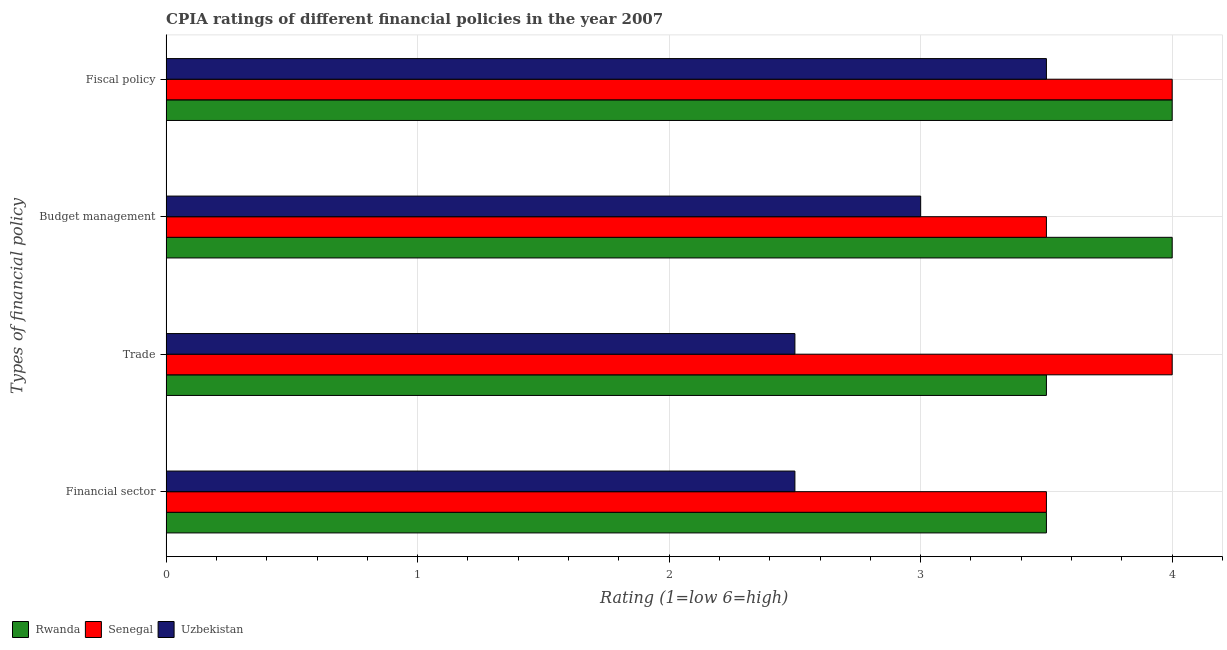How many groups of bars are there?
Keep it short and to the point. 4. Are the number of bars per tick equal to the number of legend labels?
Your response must be concise. Yes. Are the number of bars on each tick of the Y-axis equal?
Provide a short and direct response. Yes. How many bars are there on the 4th tick from the top?
Ensure brevity in your answer.  3. What is the label of the 3rd group of bars from the top?
Your answer should be very brief. Trade. Across all countries, what is the minimum cpia rating of financial sector?
Your answer should be compact. 2.5. In which country was the cpia rating of financial sector maximum?
Your answer should be compact. Rwanda. In which country was the cpia rating of trade minimum?
Provide a short and direct response. Uzbekistan. What is the total cpia rating of budget management in the graph?
Your response must be concise. 10.5. What is the difference between the cpia rating of trade in Rwanda and that in Senegal?
Your answer should be compact. -0.5. What is the difference between the cpia rating of financial sector and cpia rating of fiscal policy in Senegal?
Give a very brief answer. -0.5. What is the ratio of the cpia rating of trade in Senegal to that in Rwanda?
Give a very brief answer. 1.14. Is the cpia rating of trade in Senegal less than that in Rwanda?
Your answer should be very brief. No. In how many countries, is the cpia rating of financial sector greater than the average cpia rating of financial sector taken over all countries?
Your response must be concise. 2. Is it the case that in every country, the sum of the cpia rating of financial sector and cpia rating of fiscal policy is greater than the sum of cpia rating of trade and cpia rating of budget management?
Provide a short and direct response. No. What does the 3rd bar from the top in Fiscal policy represents?
Give a very brief answer. Rwanda. What does the 2nd bar from the bottom in Financial sector represents?
Offer a terse response. Senegal. Is it the case that in every country, the sum of the cpia rating of financial sector and cpia rating of trade is greater than the cpia rating of budget management?
Your answer should be very brief. Yes. How many countries are there in the graph?
Offer a terse response. 3. Are the values on the major ticks of X-axis written in scientific E-notation?
Make the answer very short. No. Does the graph contain any zero values?
Keep it short and to the point. No. Does the graph contain grids?
Your answer should be compact. Yes. Where does the legend appear in the graph?
Your answer should be very brief. Bottom left. What is the title of the graph?
Ensure brevity in your answer.  CPIA ratings of different financial policies in the year 2007. Does "Serbia" appear as one of the legend labels in the graph?
Offer a terse response. No. What is the label or title of the Y-axis?
Ensure brevity in your answer.  Types of financial policy. What is the Rating (1=low 6=high) of Rwanda in Financial sector?
Offer a very short reply. 3.5. What is the Rating (1=low 6=high) in Uzbekistan in Financial sector?
Provide a short and direct response. 2.5. What is the Rating (1=low 6=high) of Uzbekistan in Trade?
Make the answer very short. 2.5. What is the Rating (1=low 6=high) of Senegal in Budget management?
Give a very brief answer. 3.5. What is the Rating (1=low 6=high) of Rwanda in Fiscal policy?
Provide a short and direct response. 4. What is the Rating (1=low 6=high) in Uzbekistan in Fiscal policy?
Ensure brevity in your answer.  3.5. Across all Types of financial policy, what is the maximum Rating (1=low 6=high) of Senegal?
Your response must be concise. 4. Across all Types of financial policy, what is the maximum Rating (1=low 6=high) in Uzbekistan?
Make the answer very short. 3.5. Across all Types of financial policy, what is the minimum Rating (1=low 6=high) in Rwanda?
Provide a short and direct response. 3.5. What is the total Rating (1=low 6=high) of Rwanda in the graph?
Provide a short and direct response. 15. What is the total Rating (1=low 6=high) of Senegal in the graph?
Your response must be concise. 15. What is the difference between the Rating (1=low 6=high) in Senegal in Financial sector and that in Trade?
Your answer should be compact. -0.5. What is the difference between the Rating (1=low 6=high) in Rwanda in Financial sector and that in Budget management?
Keep it short and to the point. -0.5. What is the difference between the Rating (1=low 6=high) of Senegal in Financial sector and that in Budget management?
Offer a very short reply. 0. What is the difference between the Rating (1=low 6=high) in Senegal in Financial sector and that in Fiscal policy?
Offer a terse response. -0.5. What is the difference between the Rating (1=low 6=high) of Rwanda in Trade and that in Budget management?
Ensure brevity in your answer.  -0.5. What is the difference between the Rating (1=low 6=high) in Senegal in Trade and that in Fiscal policy?
Ensure brevity in your answer.  0. What is the difference between the Rating (1=low 6=high) of Senegal in Budget management and that in Fiscal policy?
Your response must be concise. -0.5. What is the difference between the Rating (1=low 6=high) in Rwanda in Financial sector and the Rating (1=low 6=high) in Senegal in Trade?
Offer a terse response. -0.5. What is the difference between the Rating (1=low 6=high) in Rwanda in Financial sector and the Rating (1=low 6=high) in Uzbekistan in Trade?
Your answer should be very brief. 1. What is the difference between the Rating (1=low 6=high) of Rwanda in Financial sector and the Rating (1=low 6=high) of Uzbekistan in Budget management?
Offer a very short reply. 0.5. What is the difference between the Rating (1=low 6=high) of Rwanda in Financial sector and the Rating (1=low 6=high) of Uzbekistan in Fiscal policy?
Provide a succinct answer. 0. What is the difference between the Rating (1=low 6=high) of Senegal in Trade and the Rating (1=low 6=high) of Uzbekistan in Budget management?
Your response must be concise. 1. What is the difference between the Rating (1=low 6=high) of Rwanda in Budget management and the Rating (1=low 6=high) of Uzbekistan in Fiscal policy?
Make the answer very short. 0.5. What is the average Rating (1=low 6=high) of Rwanda per Types of financial policy?
Give a very brief answer. 3.75. What is the average Rating (1=low 6=high) in Senegal per Types of financial policy?
Provide a succinct answer. 3.75. What is the average Rating (1=low 6=high) in Uzbekistan per Types of financial policy?
Offer a terse response. 2.88. What is the difference between the Rating (1=low 6=high) in Senegal and Rating (1=low 6=high) in Uzbekistan in Financial sector?
Ensure brevity in your answer.  1. What is the difference between the Rating (1=low 6=high) of Rwanda and Rating (1=low 6=high) of Senegal in Trade?
Provide a succinct answer. -0.5. What is the difference between the Rating (1=low 6=high) in Rwanda and Rating (1=low 6=high) in Uzbekistan in Trade?
Offer a terse response. 1. What is the difference between the Rating (1=low 6=high) in Rwanda and Rating (1=low 6=high) in Senegal in Budget management?
Give a very brief answer. 0.5. What is the difference between the Rating (1=low 6=high) in Rwanda and Rating (1=low 6=high) in Uzbekistan in Budget management?
Offer a terse response. 1. What is the difference between the Rating (1=low 6=high) in Senegal and Rating (1=low 6=high) in Uzbekistan in Budget management?
Offer a very short reply. 0.5. What is the difference between the Rating (1=low 6=high) of Rwanda and Rating (1=low 6=high) of Uzbekistan in Fiscal policy?
Offer a terse response. 0.5. What is the ratio of the Rating (1=low 6=high) in Rwanda in Financial sector to that in Trade?
Your response must be concise. 1. What is the ratio of the Rating (1=low 6=high) in Senegal in Financial sector to that in Trade?
Give a very brief answer. 0.88. What is the ratio of the Rating (1=low 6=high) of Uzbekistan in Financial sector to that in Trade?
Provide a succinct answer. 1. What is the ratio of the Rating (1=low 6=high) of Rwanda in Financial sector to that in Budget management?
Keep it short and to the point. 0.88. What is the ratio of the Rating (1=low 6=high) in Rwanda in Financial sector to that in Fiscal policy?
Keep it short and to the point. 0.88. What is the ratio of the Rating (1=low 6=high) of Rwanda in Trade to that in Budget management?
Provide a short and direct response. 0.88. What is the ratio of the Rating (1=low 6=high) in Senegal in Trade to that in Fiscal policy?
Give a very brief answer. 1. What is the ratio of the Rating (1=low 6=high) in Uzbekistan in Trade to that in Fiscal policy?
Offer a very short reply. 0.71. What is the ratio of the Rating (1=low 6=high) in Rwanda in Budget management to that in Fiscal policy?
Ensure brevity in your answer.  1. What is the ratio of the Rating (1=low 6=high) in Senegal in Budget management to that in Fiscal policy?
Offer a terse response. 0.88. What is the ratio of the Rating (1=low 6=high) in Uzbekistan in Budget management to that in Fiscal policy?
Ensure brevity in your answer.  0.86. What is the difference between the highest and the second highest Rating (1=low 6=high) of Rwanda?
Provide a succinct answer. 0. What is the difference between the highest and the lowest Rating (1=low 6=high) in Uzbekistan?
Provide a succinct answer. 1. 